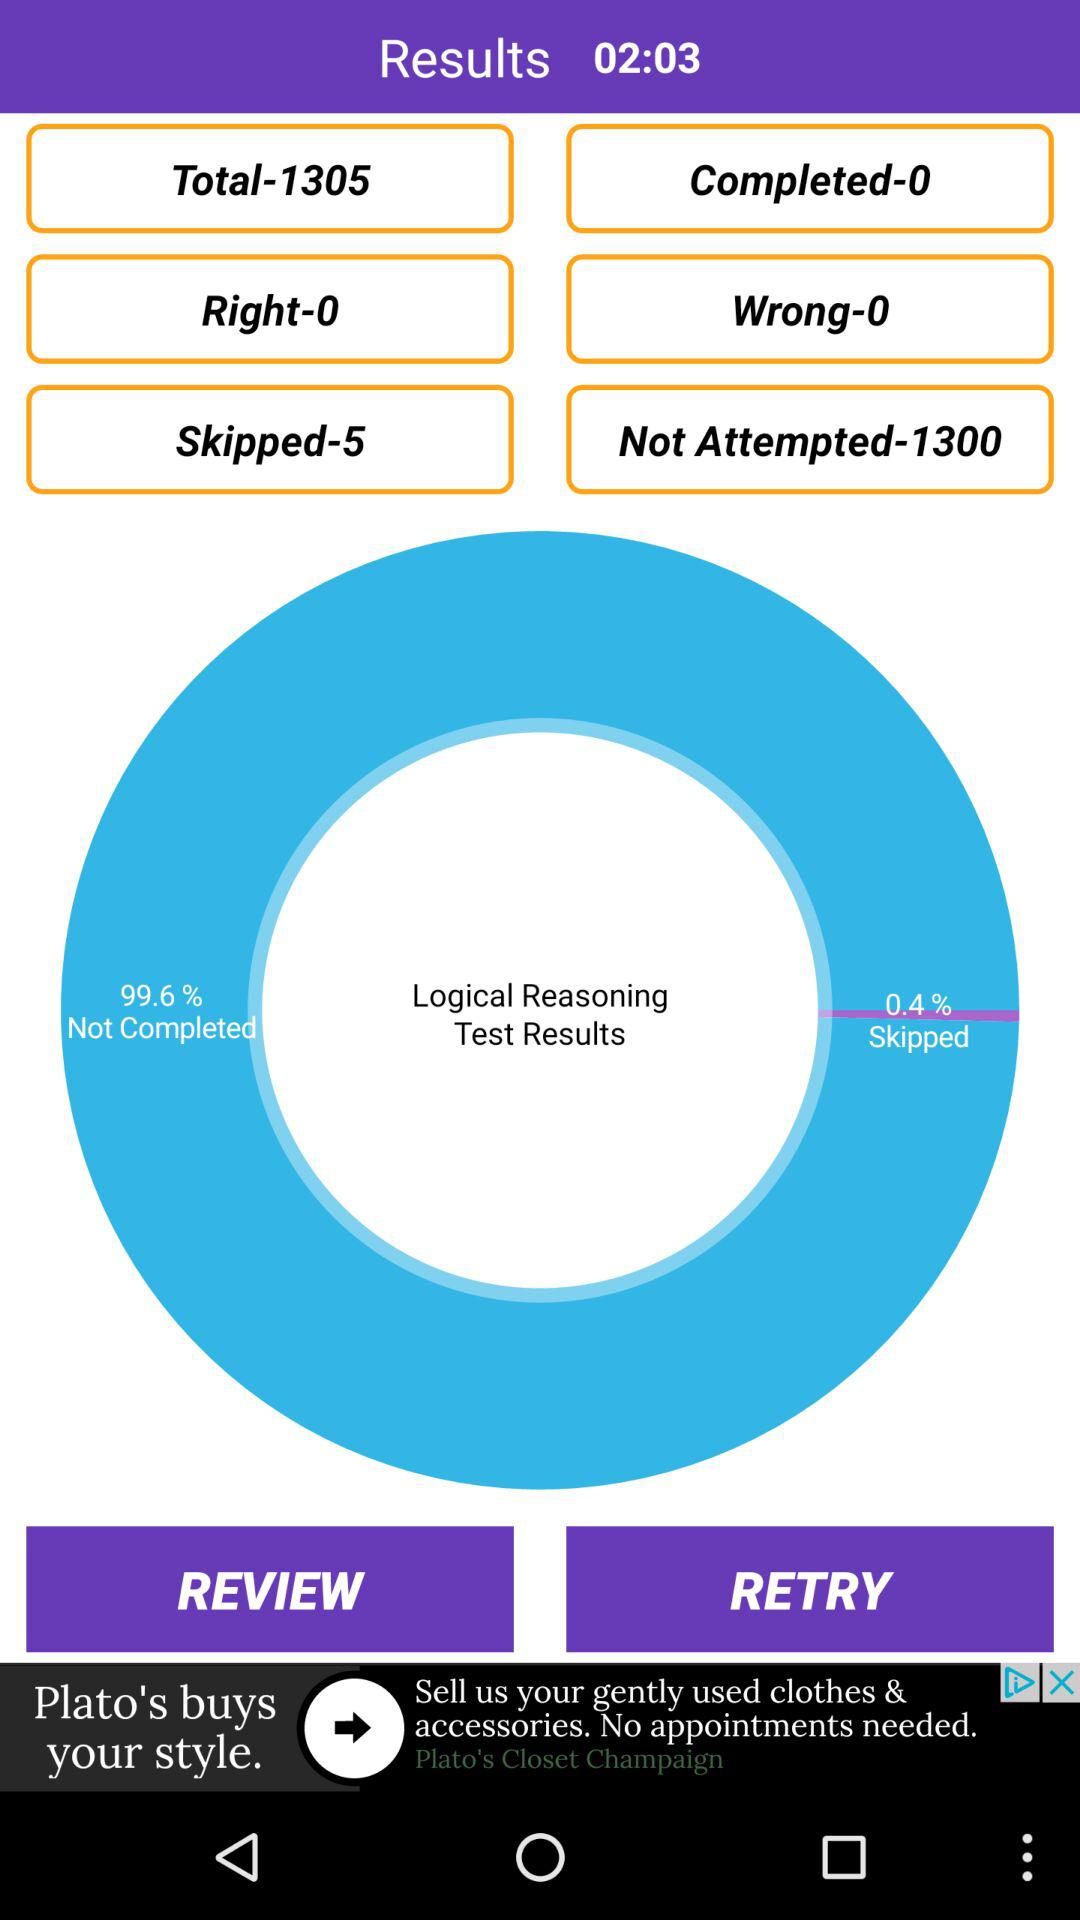How many questions are right? There are zero right questions. 